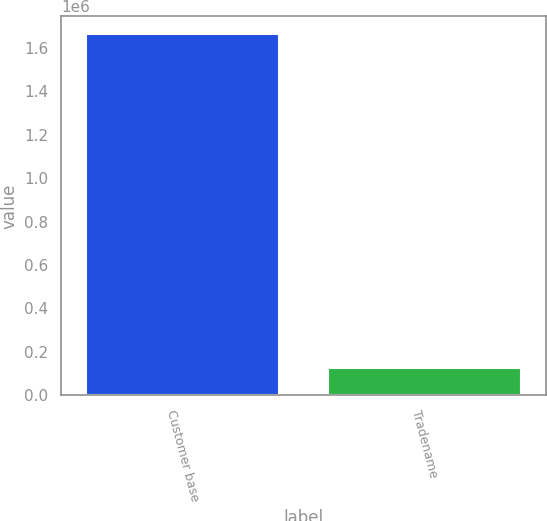Convert chart. <chart><loc_0><loc_0><loc_500><loc_500><bar_chart><fcel>Customer base<fcel>Tradename<nl><fcel>1.66168e+06<fcel>125203<nl></chart> 